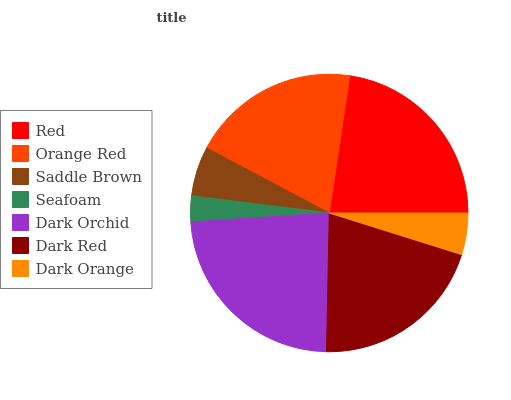Is Seafoam the minimum?
Answer yes or no. Yes. Is Dark Orchid the maximum?
Answer yes or no. Yes. Is Orange Red the minimum?
Answer yes or no. No. Is Orange Red the maximum?
Answer yes or no. No. Is Red greater than Orange Red?
Answer yes or no. Yes. Is Orange Red less than Red?
Answer yes or no. Yes. Is Orange Red greater than Red?
Answer yes or no. No. Is Red less than Orange Red?
Answer yes or no. No. Is Orange Red the high median?
Answer yes or no. Yes. Is Orange Red the low median?
Answer yes or no. Yes. Is Dark Orange the high median?
Answer yes or no. No. Is Dark Orange the low median?
Answer yes or no. No. 